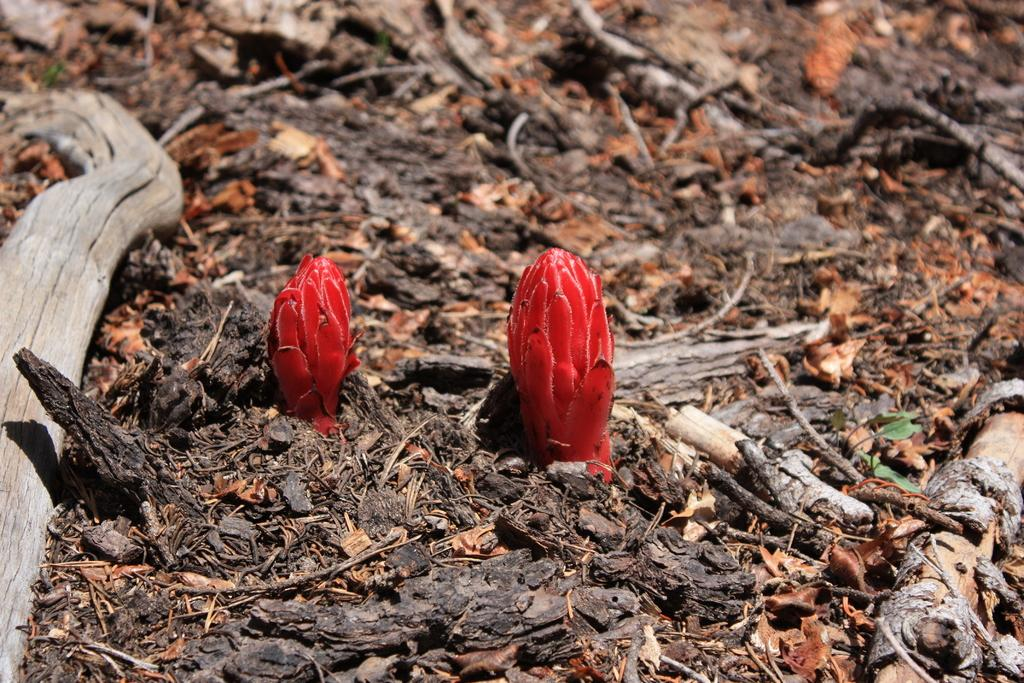What type of natural elements can be seen on the ground in the image? There are two snow flowers, wood pieces of a tree, and leaves on the ground in the image. Can you describe the condition of the image? The image is slightly blurred in this part. What type of produce is visible in the image? There is no produce present in the image; it features snow flowers, wood pieces, and leaves on the ground. Is there a crown visible in the image? There is no crown present in the image. 